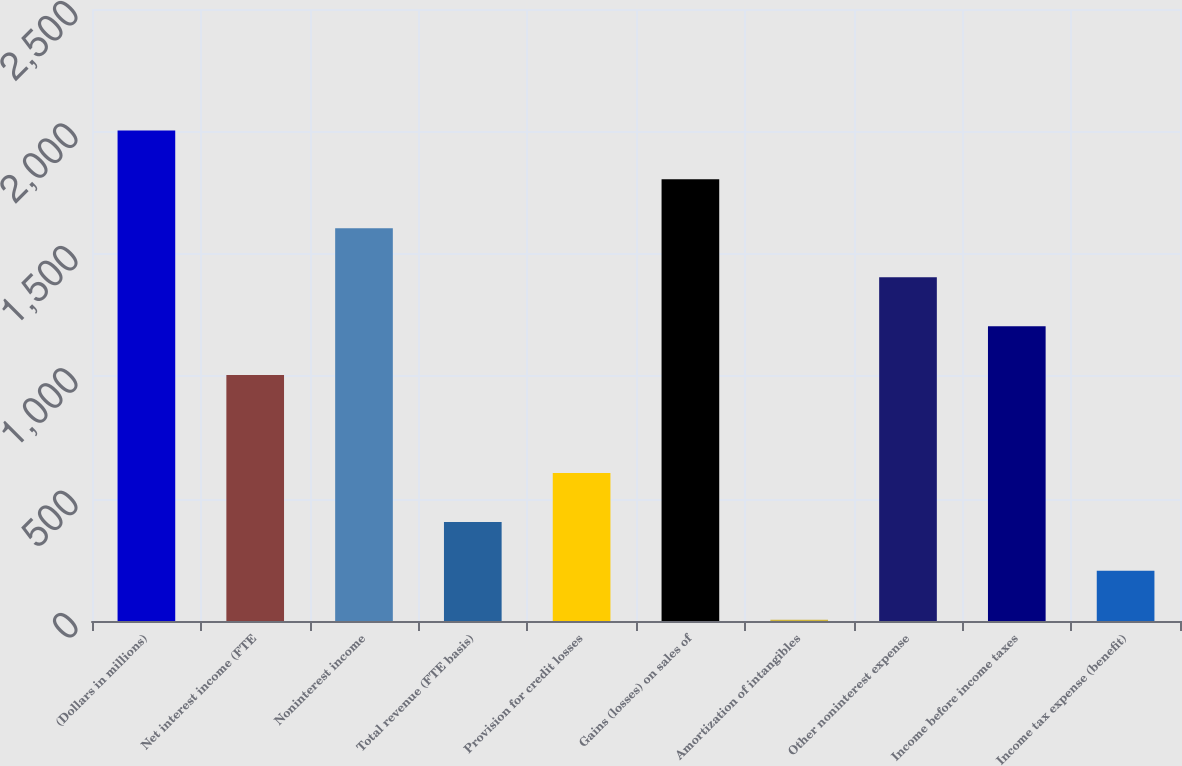Convert chart to OTSL. <chart><loc_0><loc_0><loc_500><loc_500><bar_chart><fcel>(Dollars in millions)<fcel>Net interest income (FTE<fcel>Noninterest income<fcel>Total revenue (FTE basis)<fcel>Provision for credit losses<fcel>Gains (losses) on sales of<fcel>Amortization of intangibles<fcel>Other noninterest expense<fcel>Income before income taxes<fcel>Income tax expense (benefit)<nl><fcel>2004<fcel>1004.5<fcel>1604.2<fcel>404.8<fcel>604.7<fcel>1804.1<fcel>5<fcel>1404.3<fcel>1204.4<fcel>204.9<nl></chart> 